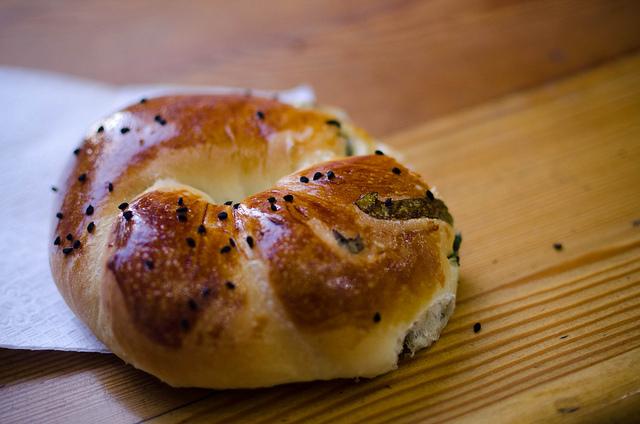Is this food wrapped in plastic?
Write a very short answer. No. Is this a donut?
Concise answer only. No. Are these doughnuts or bagels?
Give a very brief answer. Bagel. Are there seeds on the bagel?
Quick response, please. Yes. Is this pastry whole?
Quick response, please. Yes. 